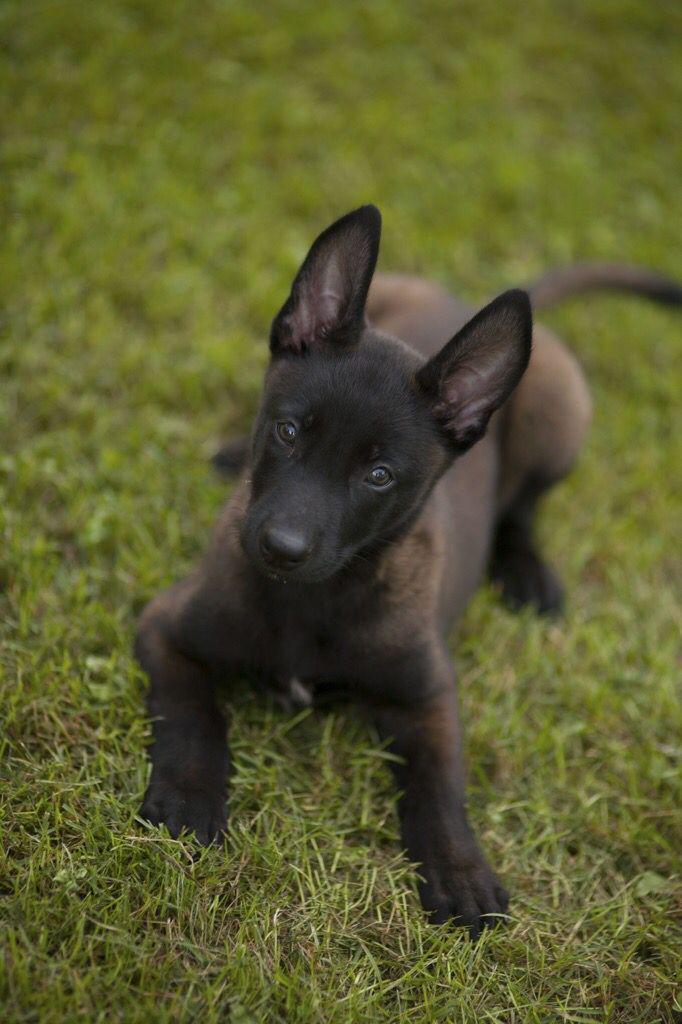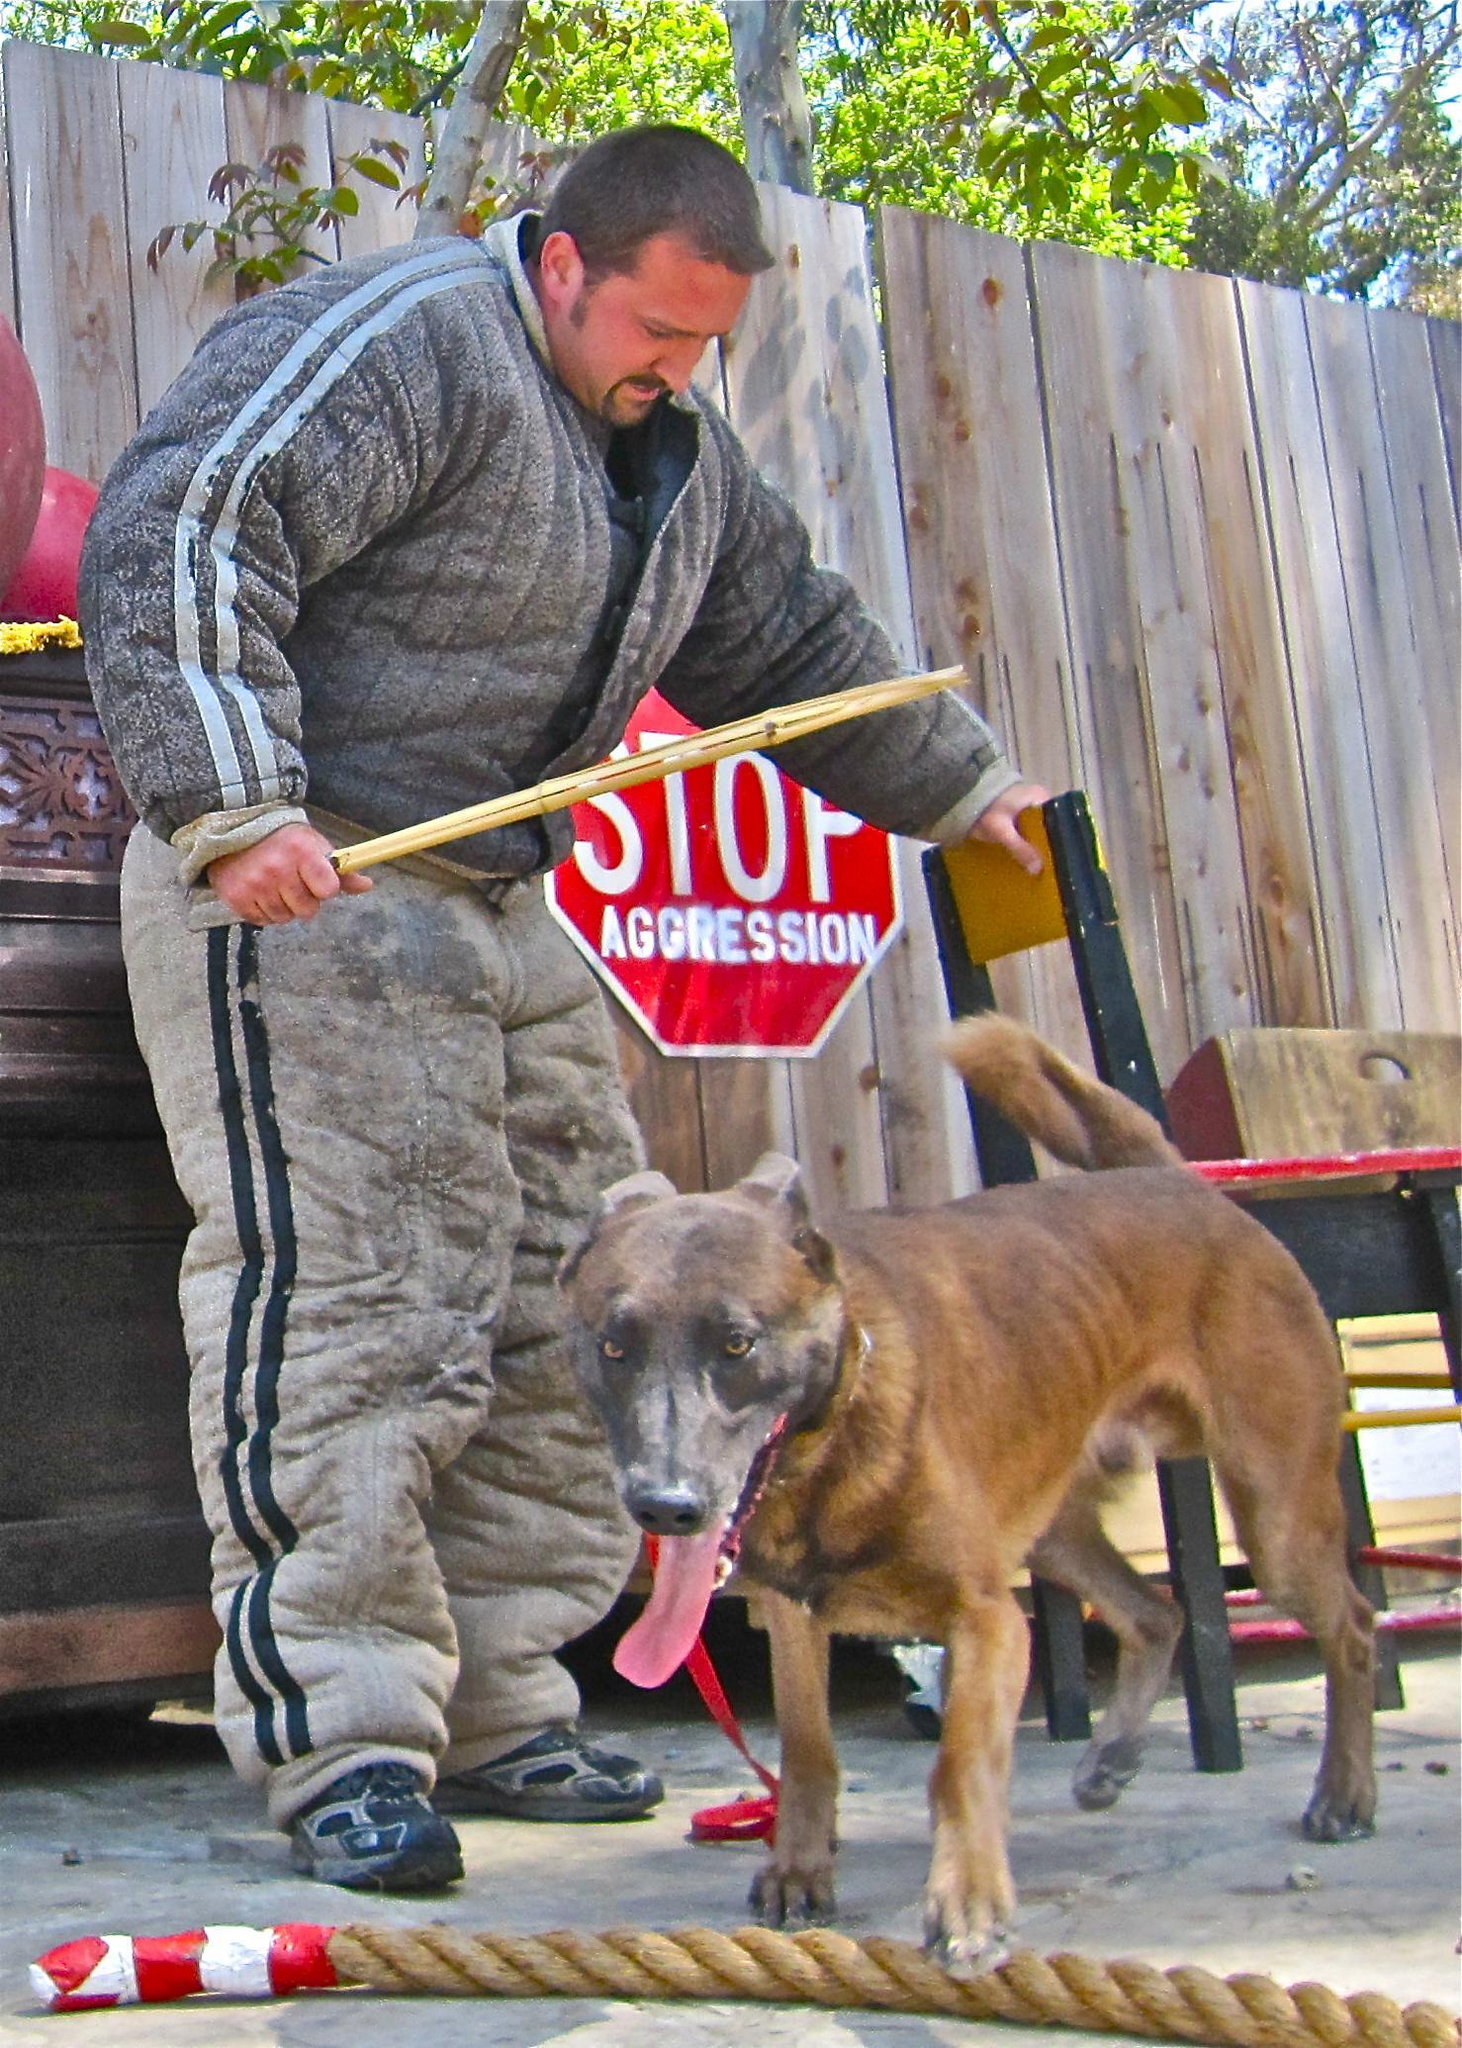The first image is the image on the left, the second image is the image on the right. Assess this claim about the two images: "There are three adult German Shepherds sitting in the grass.". Correct or not? Answer yes or no. No. 